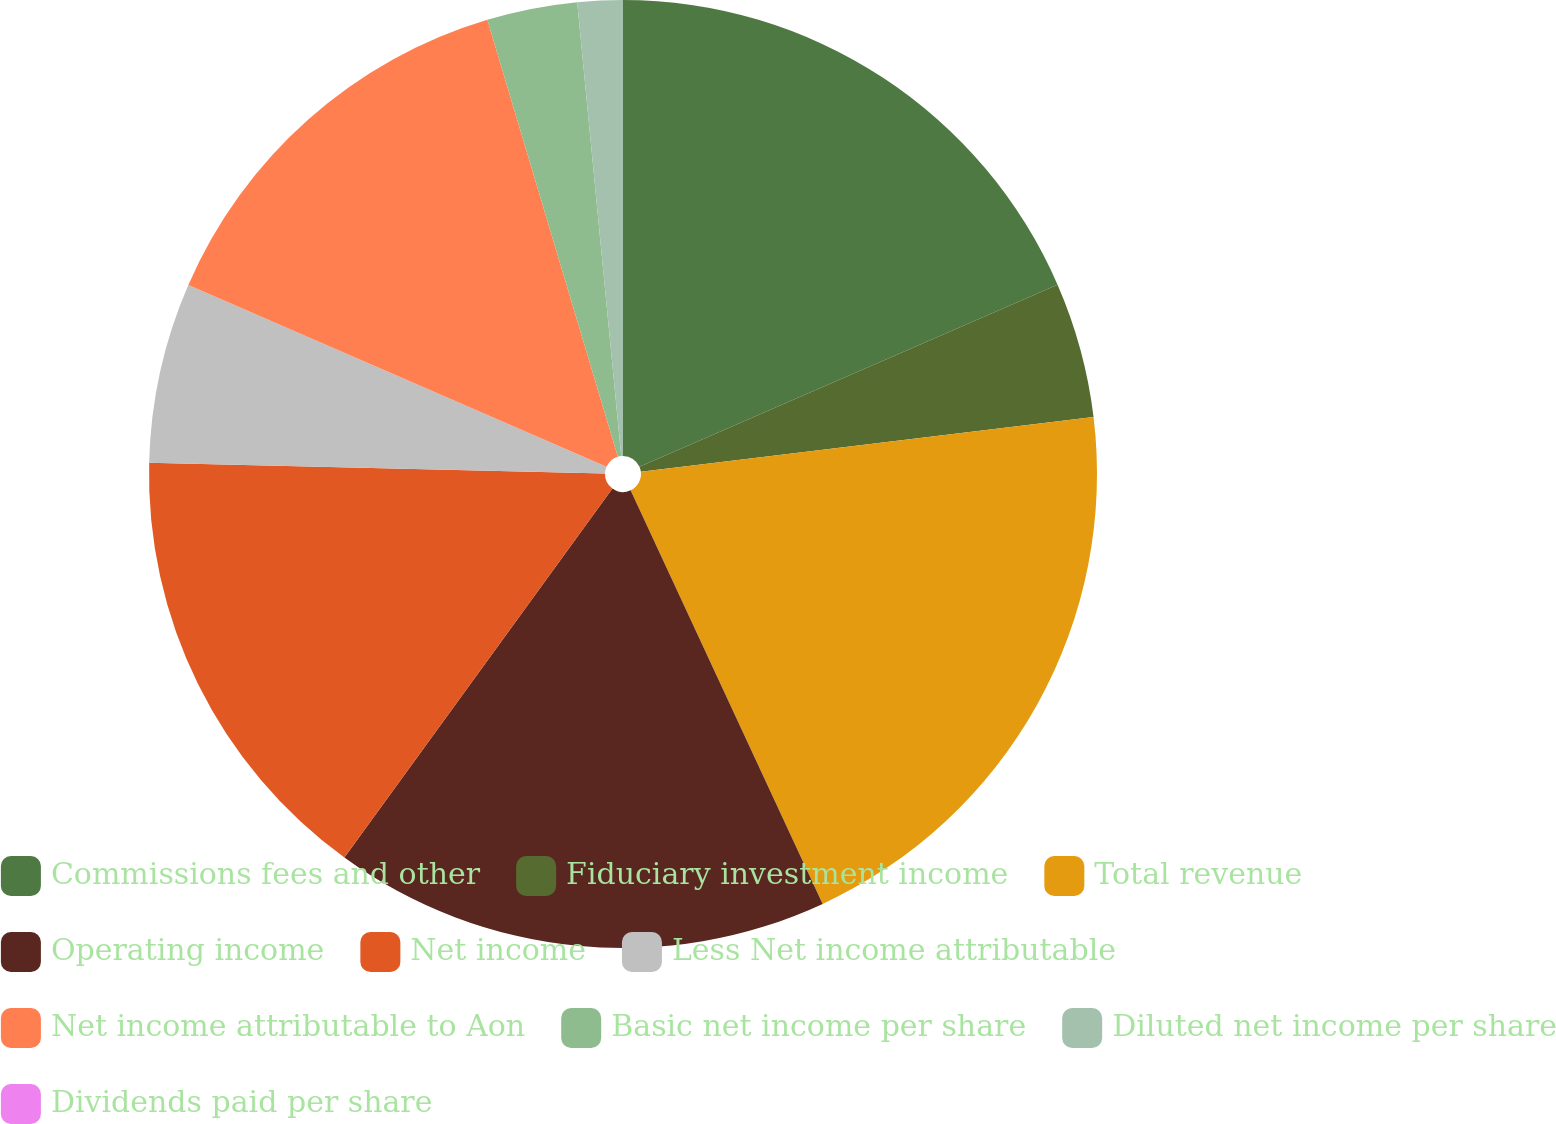Convert chart to OTSL. <chart><loc_0><loc_0><loc_500><loc_500><pie_chart><fcel>Commissions fees and other<fcel>Fiduciary investment income<fcel>Total revenue<fcel>Operating income<fcel>Net income<fcel>Less Net income attributable<fcel>Net income attributable to Aon<fcel>Basic net income per share<fcel>Diluted net income per share<fcel>Dividends paid per share<nl><fcel>18.46%<fcel>4.62%<fcel>20.0%<fcel>16.92%<fcel>15.38%<fcel>6.15%<fcel>13.85%<fcel>3.08%<fcel>1.54%<fcel>0.0%<nl></chart> 